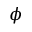<formula> <loc_0><loc_0><loc_500><loc_500>\phi</formula> 